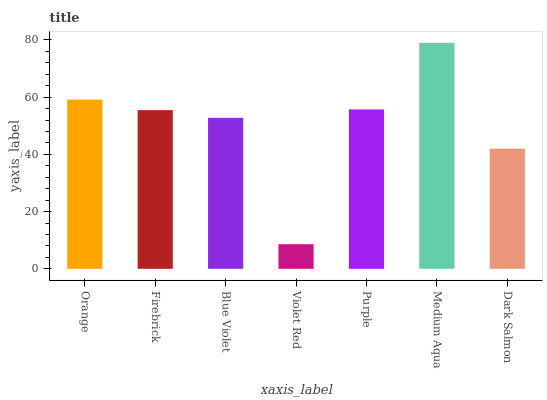Is Violet Red the minimum?
Answer yes or no. Yes. Is Medium Aqua the maximum?
Answer yes or no. Yes. Is Firebrick the minimum?
Answer yes or no. No. Is Firebrick the maximum?
Answer yes or no. No. Is Orange greater than Firebrick?
Answer yes or no. Yes. Is Firebrick less than Orange?
Answer yes or no. Yes. Is Firebrick greater than Orange?
Answer yes or no. No. Is Orange less than Firebrick?
Answer yes or no. No. Is Firebrick the high median?
Answer yes or no. Yes. Is Firebrick the low median?
Answer yes or no. Yes. Is Orange the high median?
Answer yes or no. No. Is Orange the low median?
Answer yes or no. No. 